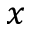<formula> <loc_0><loc_0><loc_500><loc_500>x</formula> 